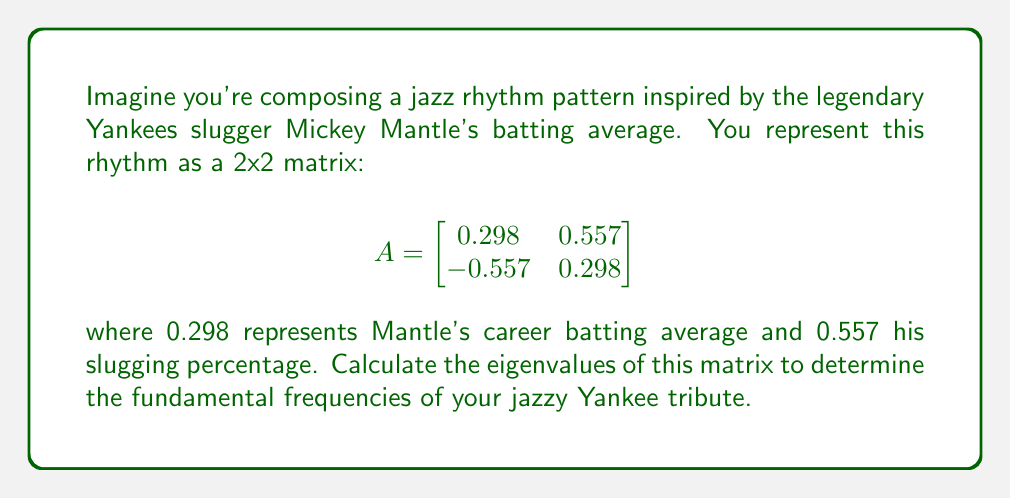Solve this math problem. To find the eigenvalues of matrix A, we need to solve the characteristic equation:

det$(A - \lambda I) = 0$

where $\lambda$ represents the eigenvalues and I is the 2x2 identity matrix.

Step 1: Set up the characteristic equation
$$\begin{vmatrix}
0.298 - \lambda & 0.557 \\
-0.557 & 0.298 - \lambda
\end{vmatrix} = 0$$

Step 2: Calculate the determinant
$(0.298 - \lambda)(0.298 - \lambda) - (-0.557)(0.557) = 0$

Step 3: Expand the equation
$\lambda^2 - 0.596\lambda + 0.088804 + 0.310249 = 0$
$\lambda^2 - 0.596\lambda + 0.399053 = 0$

Step 4: Solve the quadratic equation using the quadratic formula
$\lambda = \frac{-b \pm \sqrt{b^2 - 4ac}}{2a}$

Where $a=1$, $b=-0.596$, and $c=0.399053$

$\lambda = \frac{0.596 \pm \sqrt{0.596^2 - 4(1)(0.399053)}}{2(1)}$
$\lambda = \frac{0.596 \pm \sqrt{0.355216 - 1.596212}}{2}$
$\lambda = \frac{0.596 \pm \sqrt{-1.240996}}{2}$
$\lambda = \frac{0.596 \pm 1.114i}{2}$

Step 5: Simplify the results
$\lambda_1 = 0.298 + 0.557i$
$\lambda_2 = 0.298 - 0.557i$
Answer: $\lambda_1 = 0.298 + 0.557i$, $\lambda_2 = 0.298 - 0.557i$ 